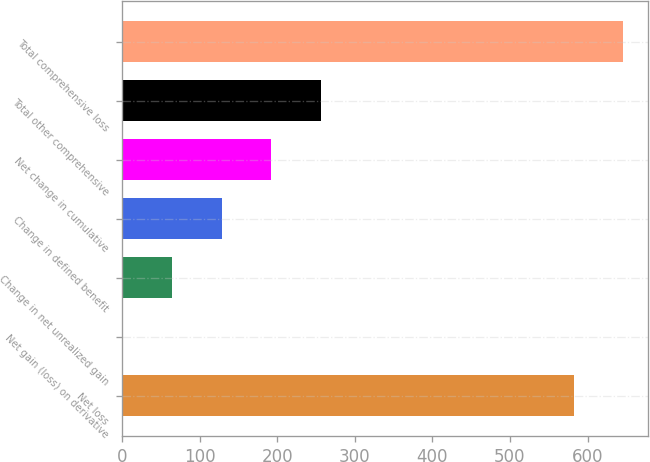<chart> <loc_0><loc_0><loc_500><loc_500><bar_chart><fcel>Net loss<fcel>Net gain (loss) on derivative<fcel>Change in net unrealized gain<fcel>Change in defined benefit<fcel>Net change in cumulative<fcel>Total other comprehensive<fcel>Total comprehensive loss<nl><fcel>582.1<fcel>1.1<fcel>64.94<fcel>128.78<fcel>192.62<fcel>256.46<fcel>645.94<nl></chart> 